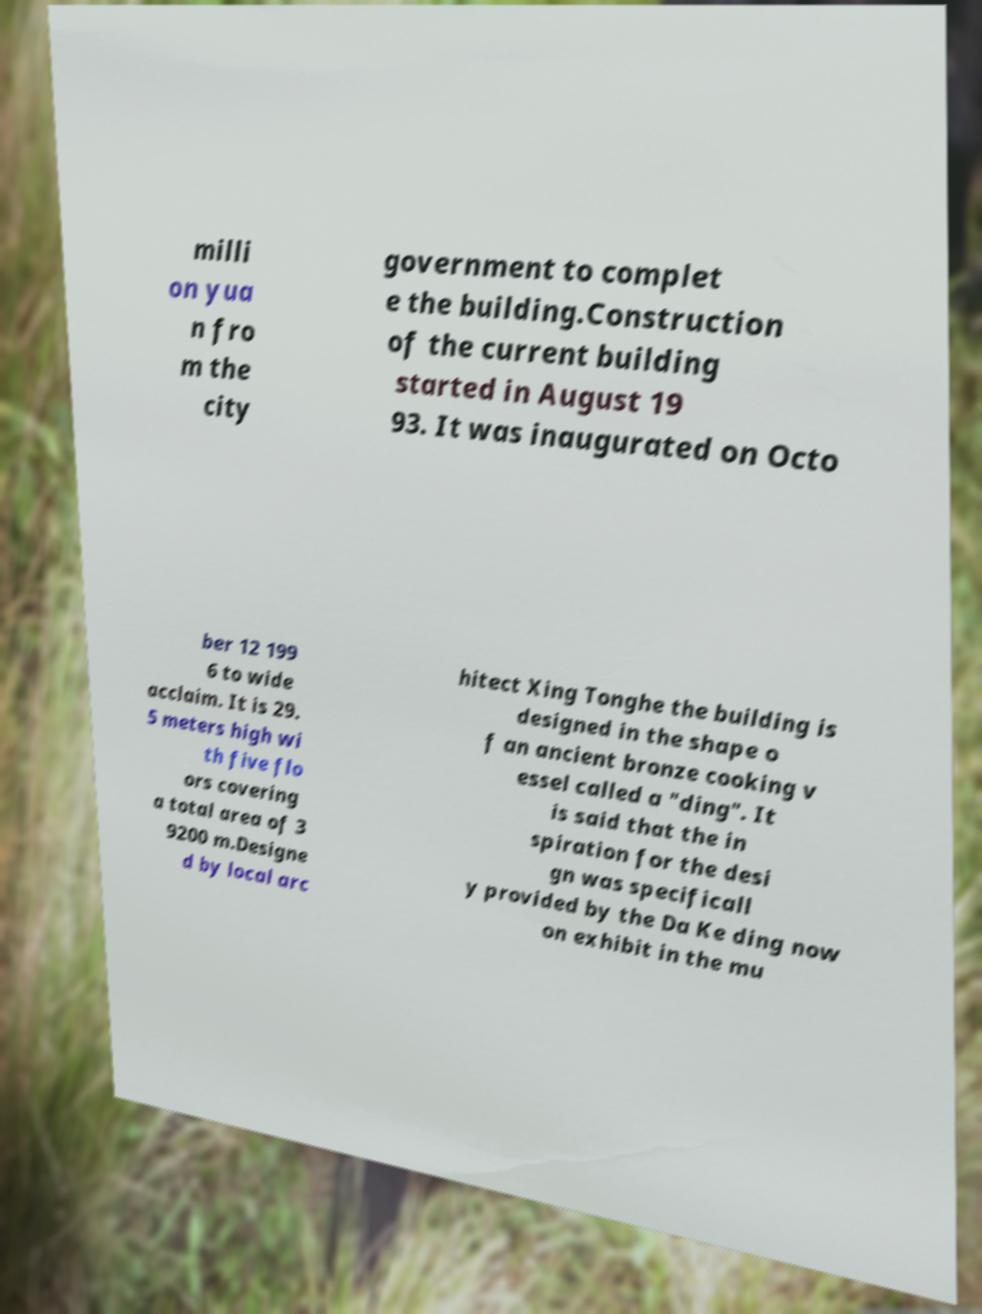Please read and relay the text visible in this image. What does it say? milli on yua n fro m the city government to complet e the building.Construction of the current building started in August 19 93. It was inaugurated on Octo ber 12 199 6 to wide acclaim. It is 29. 5 meters high wi th five flo ors covering a total area of 3 9200 m.Designe d by local arc hitect Xing Tonghe the building is designed in the shape o f an ancient bronze cooking v essel called a "ding". It is said that the in spiration for the desi gn was specificall y provided by the Da Ke ding now on exhibit in the mu 